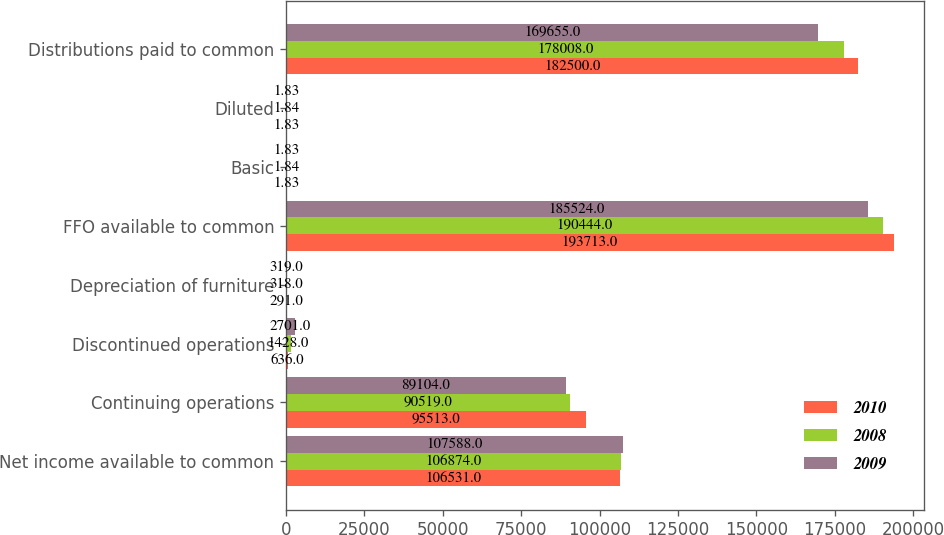Convert chart. <chart><loc_0><loc_0><loc_500><loc_500><stacked_bar_chart><ecel><fcel>Net income available to common<fcel>Continuing operations<fcel>Discontinued operations<fcel>Depreciation of furniture<fcel>FFO available to common<fcel>Basic<fcel>Diluted<fcel>Distributions paid to common<nl><fcel>2010<fcel>106531<fcel>95513<fcel>636<fcel>291<fcel>193713<fcel>1.83<fcel>1.83<fcel>182500<nl><fcel>2008<fcel>106874<fcel>90519<fcel>1428<fcel>318<fcel>190444<fcel>1.84<fcel>1.84<fcel>178008<nl><fcel>2009<fcel>107588<fcel>89104<fcel>2701<fcel>319<fcel>185524<fcel>1.83<fcel>1.83<fcel>169655<nl></chart> 